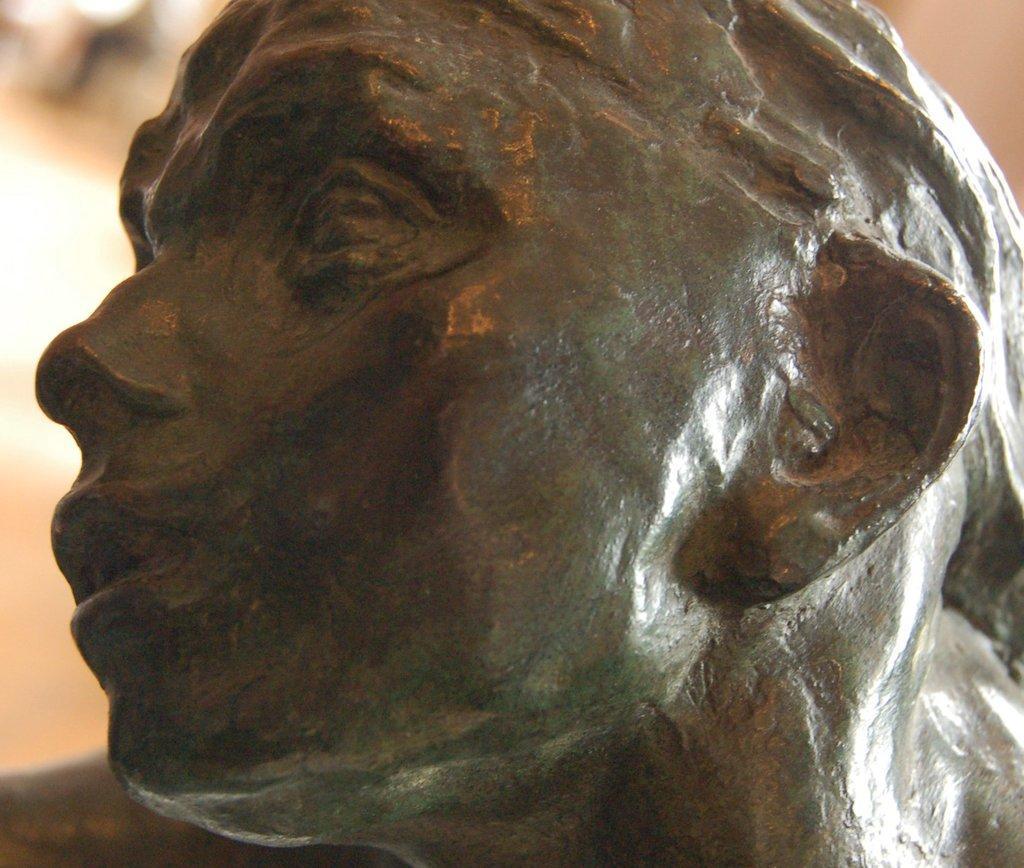Describe this image in one or two sentences. In this image I can see a sculpture of a head of a person. I can also see this image is little bit blurry from background. 